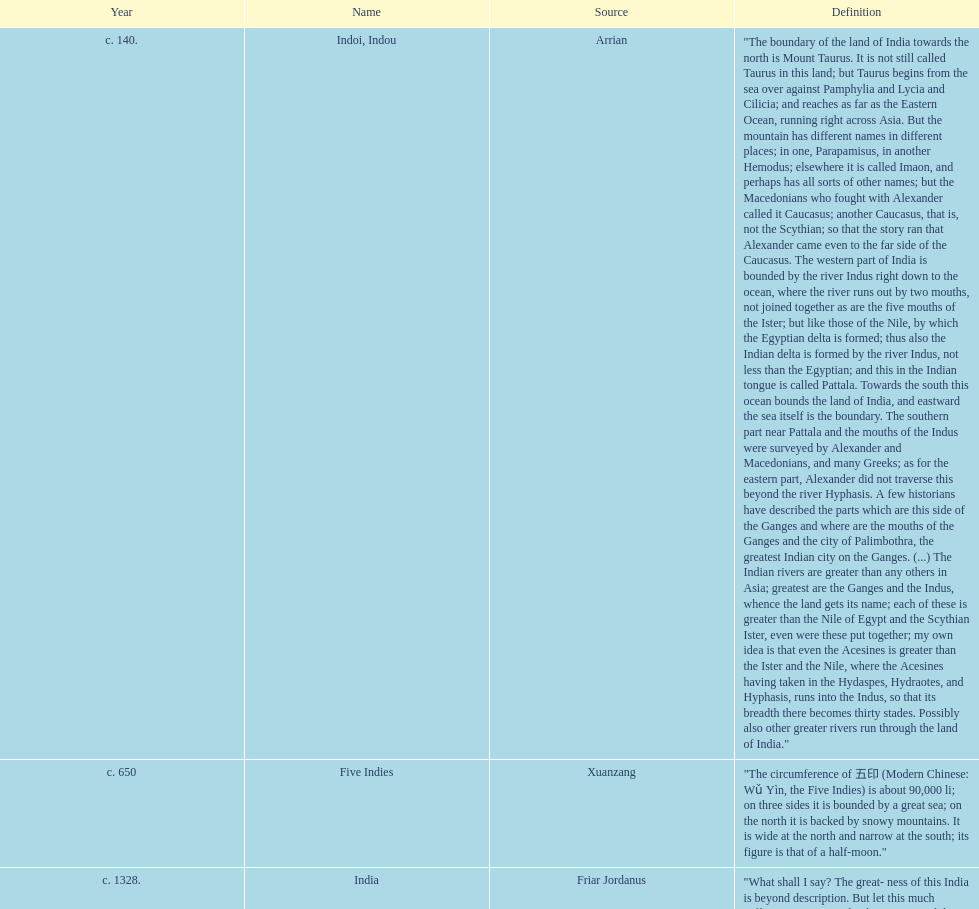What was the nation called before the book of esther called it hodu? Hidush. 